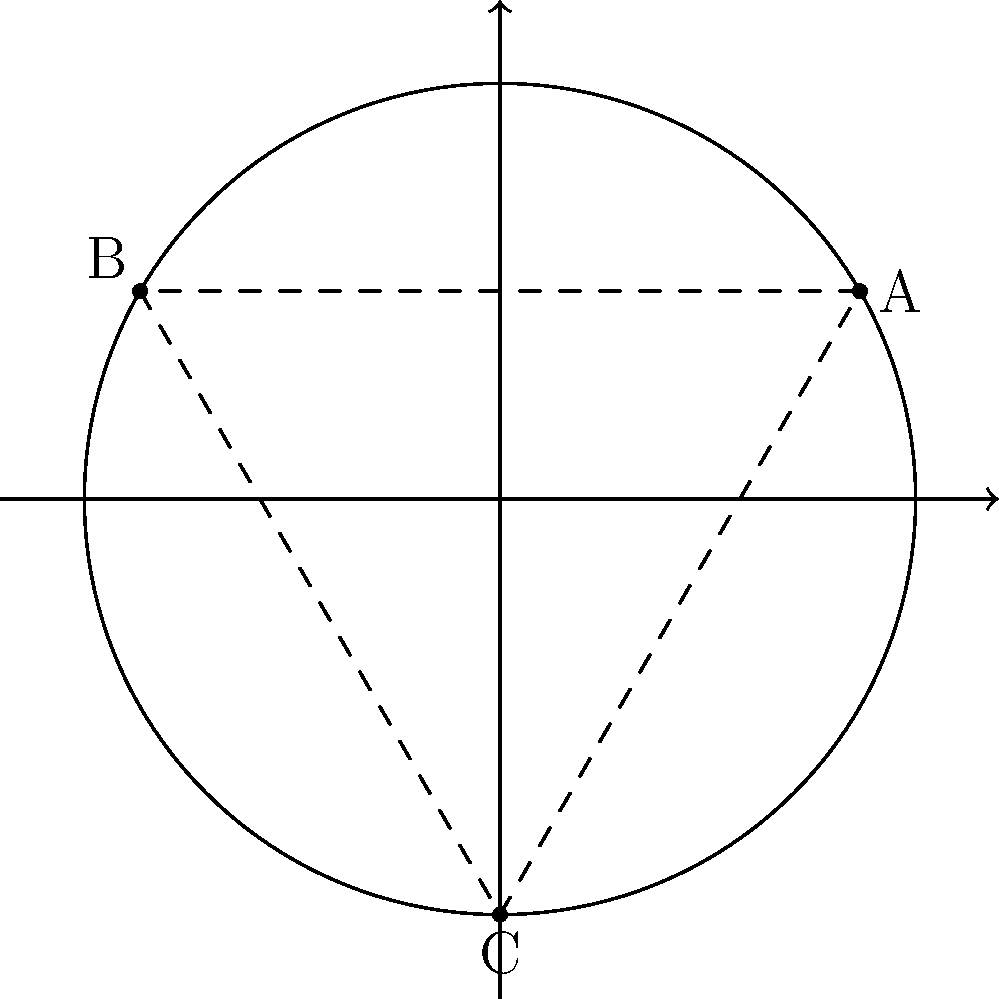In a circular stage with a radius of 5 units, three actors are positioned as follows:
Actor A at $(5, 30°)$
Actor B at $(5, 150°)$
Actor C at $(5, 270°)$
Calculate the total distance traveled by an actor moving from A to B to C and back to A along the perimeter of the stage. Express your answer in terms of $\pi$. Let's approach this step-by-step:

1) In polar coordinates, the angle between two points on a circle represents the fraction of the circumference between them.

2) To calculate the distance, we need to find the central angles between each pair of points:
   A to B: $150° - 30° = 120°$
   B to C: $270° - 150° = 120°$
   C to A: $360° - 270° + 30° = 120°$

3) Each of these angles is $\frac{1}{3}$ of a full circle ($360°$).

4) The circumference of the stage is $2\pi r = 2\pi(5) = 10\pi$ units.

5) The distance traveled between each pair of points is $\frac{1}{3}$ of the circumference:
   $\frac{1}{3} \cdot 10\pi = \frac{10\pi}{3}$ units

6) The actor travels this distance three times (A to B, B to C, C to A).

7) Therefore, the total distance is:
   $3 \cdot \frac{10\pi}{3} = 10\pi$ units
Answer: $10\pi$ units 